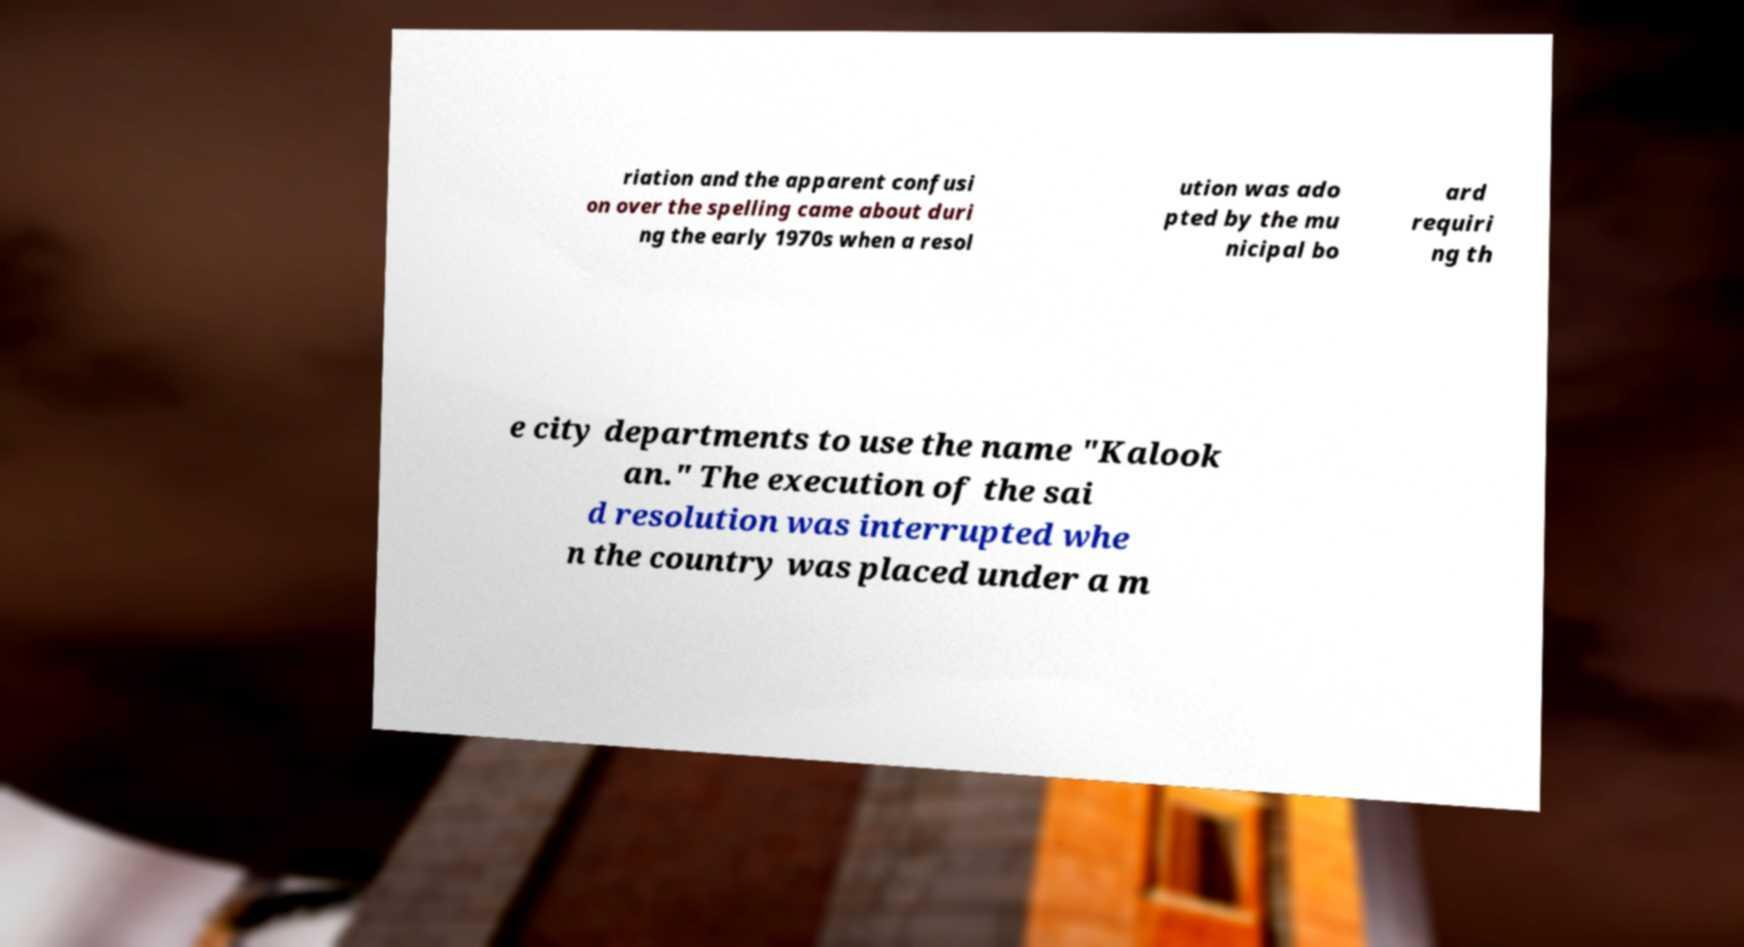Please identify and transcribe the text found in this image. riation and the apparent confusi on over the spelling came about duri ng the early 1970s when a resol ution was ado pted by the mu nicipal bo ard requiri ng th e city departments to use the name "Kalook an." The execution of the sai d resolution was interrupted whe n the country was placed under a m 